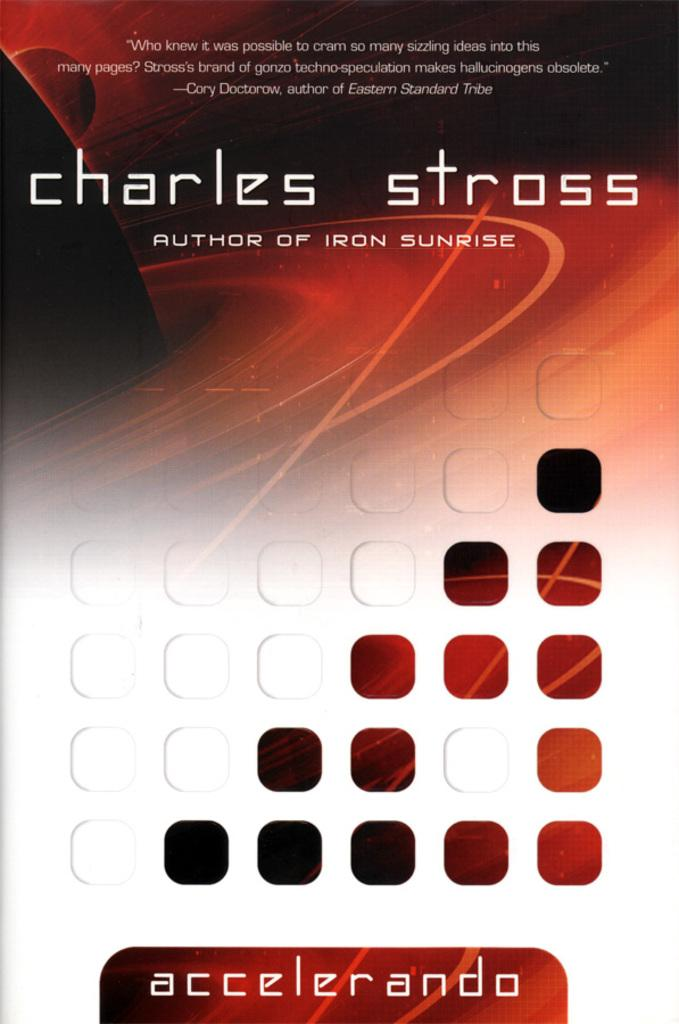<image>
Relay a brief, clear account of the picture shown. The book cover of Accelerando written by Charles Stross. 